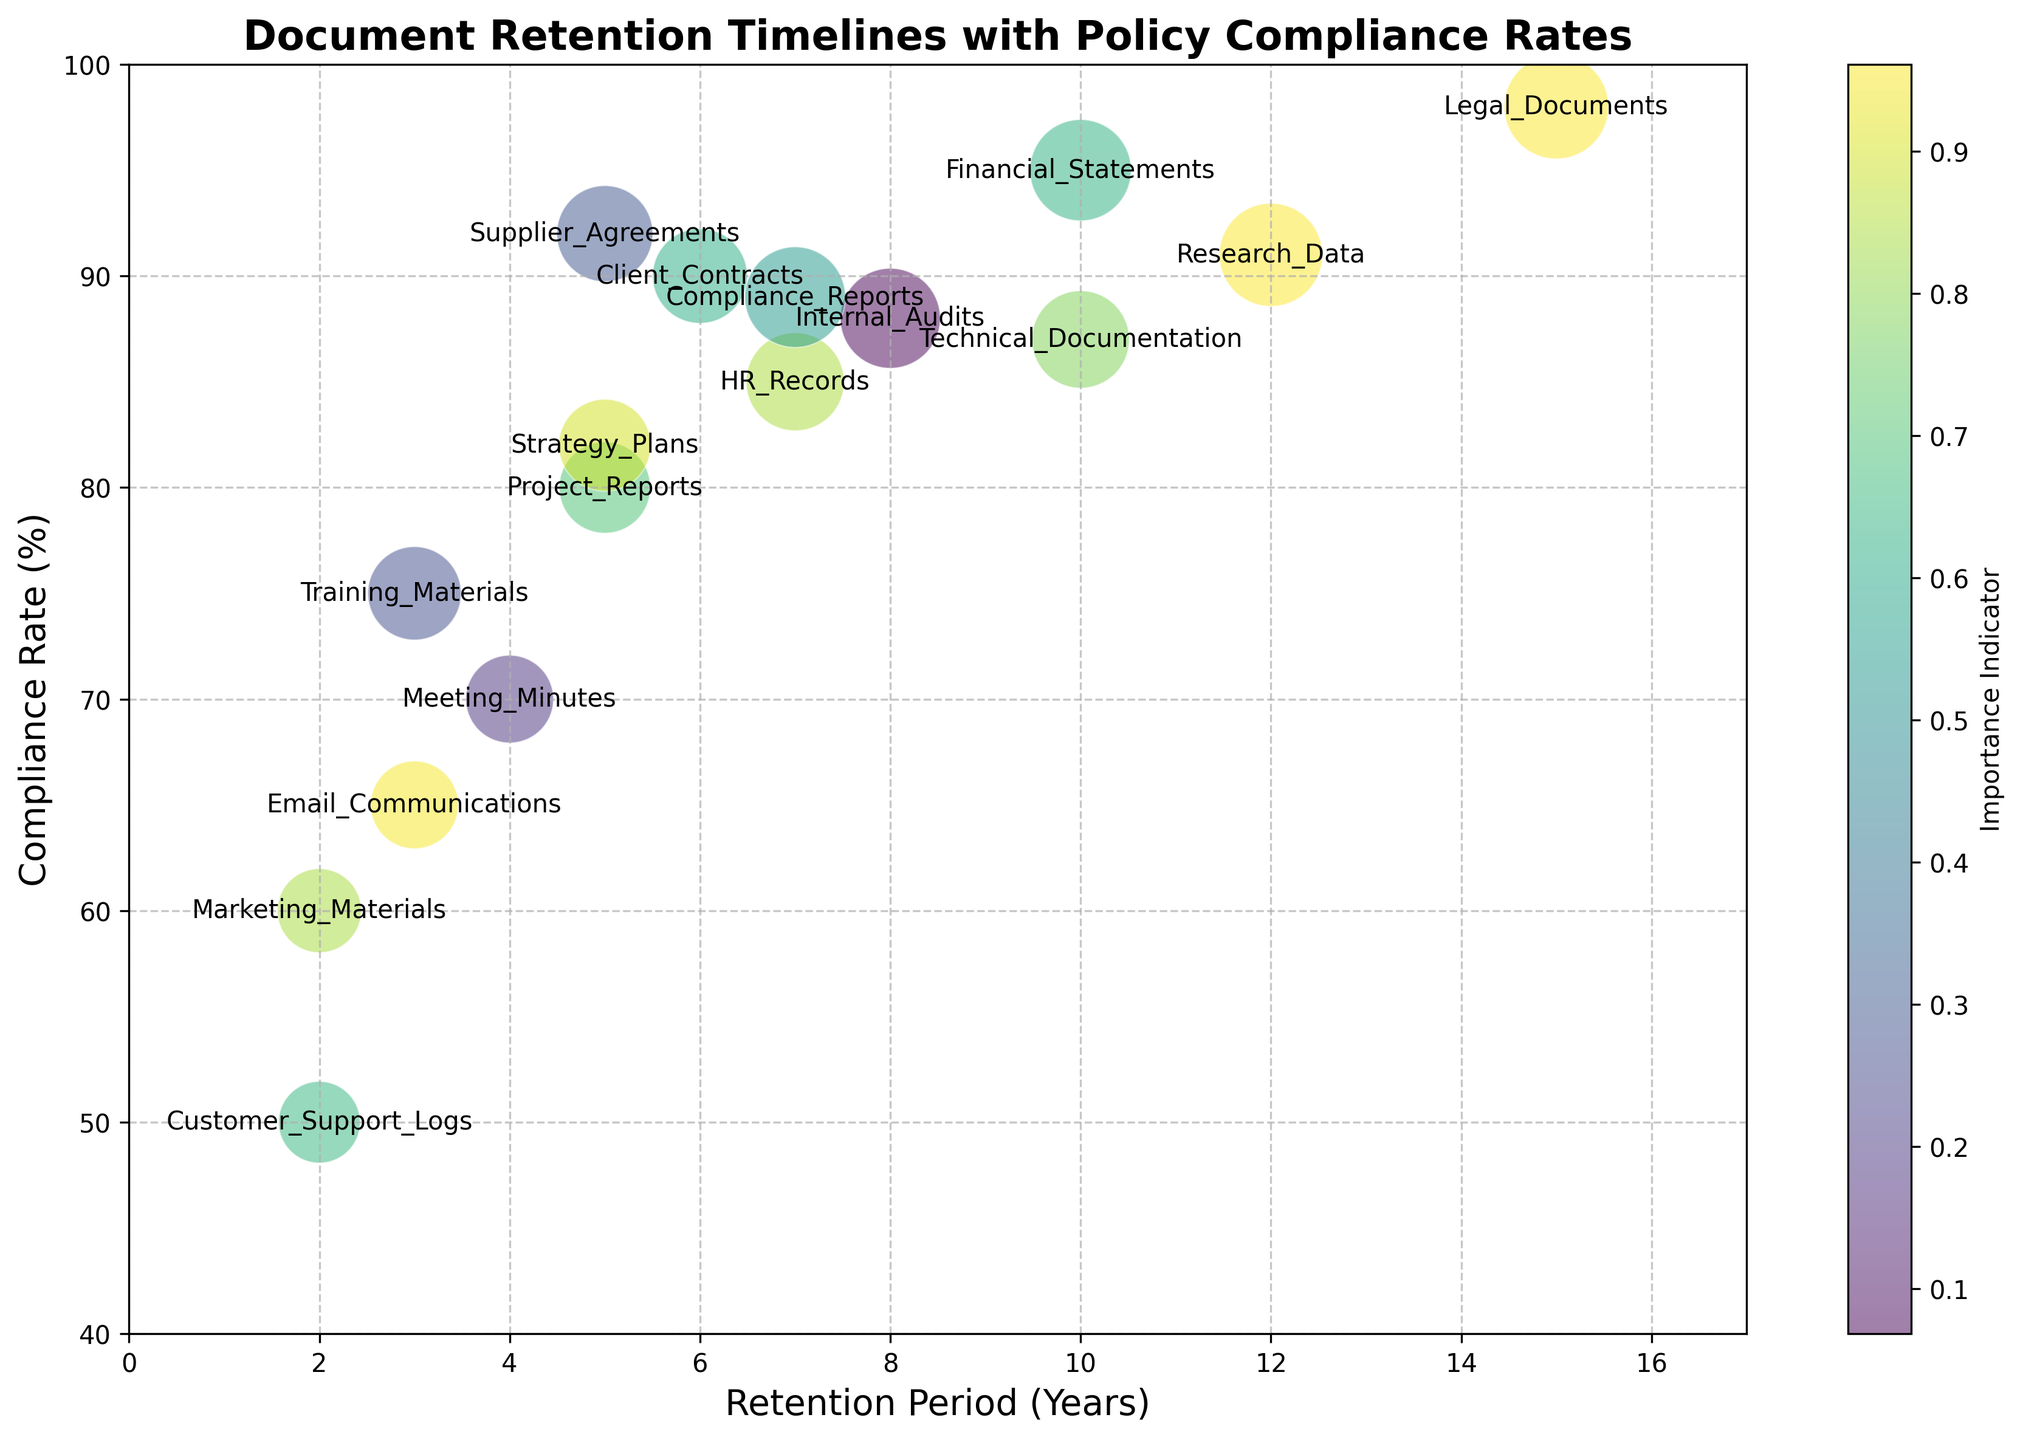What document type has the highest compliance rate? First, look for the bubble with the highest position on the y-axis. The highest point on the y-axis (98%) corresponds to Legal Documents.
Answer: Legal Documents What is the retention period for the document type with the lowest compliance rate? Look for the bubble that is positioned lowest on the y-axis to find the lowest compliance rate. The lowest point on the y-axis (50%) corresponds to Customer Support Logs. From there, map this point to the x-axis to find the retention period (2 years).
Answer: 2 years Which document types have a compliance rate above 90%? Identify the bubbles that are positioned above the 90% mark on the y-axis. These are Financial Statements, Client Contracts, Legal Documents, Research Data, and Supplier Agreements.
Answer: Financial Statements, Client Contracts, Legal Documents, Research Data, Supplier Agreements What is the combined importance of document types with a retention period of 5 years? Identify the bubbles on the x-axis at the 5-year mark. The document types are Project Reports (65), Supplier Agreements (72), and Strategy Plans (66). Combine their importance scores: 65 + 72 + 66 = 203.
Answer: 203 Which document type has the largest bubble and what does it signify? Identify the bubble with the largest size, which signifies the highest importance value. The largest bubble belongs to Legal Documents with an importance value of 85.
Answer: Legal Documents, importance of 85 Which document type has the shortest retention period and what is its compliance rate? Identify the bubble positioned furthest left on the x-axis, which will indicate the shortest retention period. This bubble belongs to Marketing Materials and has a retention period of 2 years. Its compliance rate is 60%.
Answer: Marketing Materials, 60% What is the average compliance rate for document types with a retention period of 3 years? Identify the bubbles at the 3-year mark on the x-axis. The document types are Email Communications (65%) and Training Materials (75%). Average their compliance rates: (65 + 75) / 2 = 70%.
Answer: 70% How does the compliance rate of Legal Documents compare to Financial Statements? Look at the y-axis positions of the bubbles for Legal Documents (98%) and Financial Statements (95%). Legal Documents have a higher compliance rate (98%) compared to Financial Statements (95%).
Answer: Higher What is the range of retention periods for document types with compliance rates below 70%? Identify the bubbles below the 70% mark on the y-axis. These are Marketing Materials (2 years) and Customer Support Logs (2 years). The range of retention periods is 2 - 2 years = 0 years.
Answer: 0 years Which document type with an importance score above 80 has the lowest compliance rate? First, identify bubbles with an importance score above 80. These are Financial Statements (95%), Legal Documents (98%), Research Data (91%), and Compliance Reports (89%). Among these, Compliance Reports have the lowest compliance rate of 89%.
Answer: Compliance Reports 